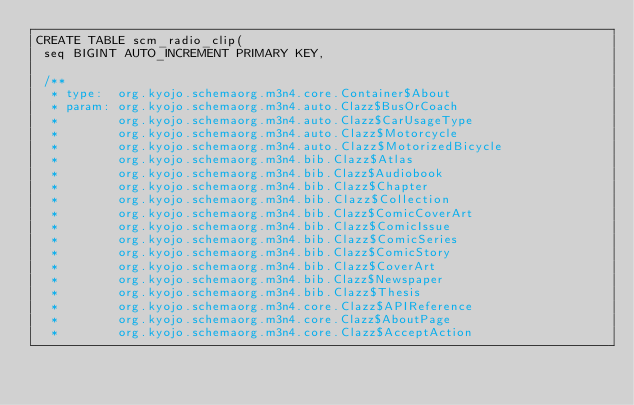<code> <loc_0><loc_0><loc_500><loc_500><_SQL_>CREATE TABLE scm_radio_clip(
 seq BIGINT AUTO_INCREMENT PRIMARY KEY,

 /**
  * type:  org.kyojo.schemaorg.m3n4.core.Container$About
  * param: org.kyojo.schemaorg.m3n4.auto.Clazz$BusOrCoach
  *        org.kyojo.schemaorg.m3n4.auto.Clazz$CarUsageType
  *        org.kyojo.schemaorg.m3n4.auto.Clazz$Motorcycle
  *        org.kyojo.schemaorg.m3n4.auto.Clazz$MotorizedBicycle
  *        org.kyojo.schemaorg.m3n4.bib.Clazz$Atlas
  *        org.kyojo.schemaorg.m3n4.bib.Clazz$Audiobook
  *        org.kyojo.schemaorg.m3n4.bib.Clazz$Chapter
  *        org.kyojo.schemaorg.m3n4.bib.Clazz$Collection
  *        org.kyojo.schemaorg.m3n4.bib.Clazz$ComicCoverArt
  *        org.kyojo.schemaorg.m3n4.bib.Clazz$ComicIssue
  *        org.kyojo.schemaorg.m3n4.bib.Clazz$ComicSeries
  *        org.kyojo.schemaorg.m3n4.bib.Clazz$ComicStory
  *        org.kyojo.schemaorg.m3n4.bib.Clazz$CoverArt
  *        org.kyojo.schemaorg.m3n4.bib.Clazz$Newspaper
  *        org.kyojo.schemaorg.m3n4.bib.Clazz$Thesis
  *        org.kyojo.schemaorg.m3n4.core.Clazz$APIReference
  *        org.kyojo.schemaorg.m3n4.core.Clazz$AboutPage
  *        org.kyojo.schemaorg.m3n4.core.Clazz$AcceptAction</code> 